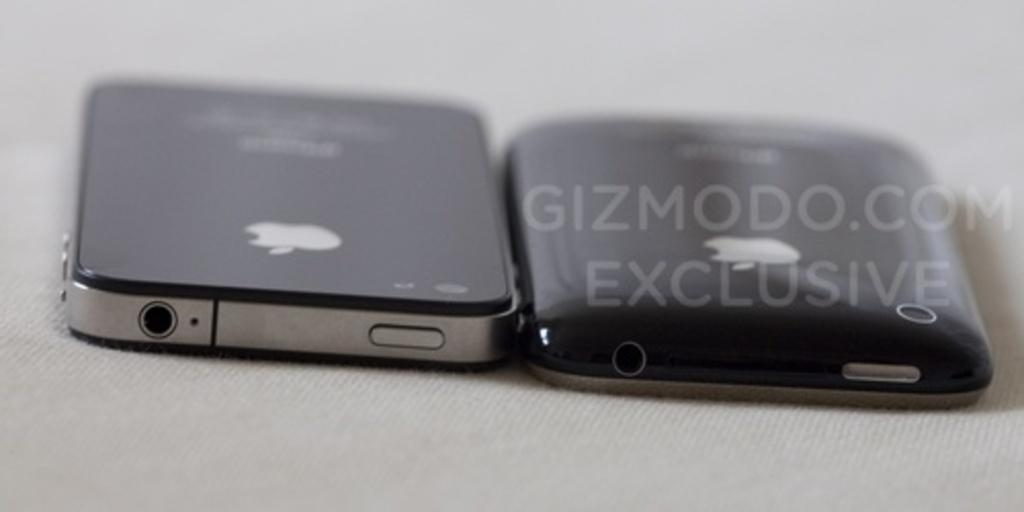What electronic devices are in the image? There are two iPhones in the image. Where are the iPhones located in the image? The iPhones are in the center of the image. What piece of furniture is at the bottom of the image? There is a table at the bottom of the image. What type of soap is being used to clean the river in the image? There is no river or soap present in the image. 